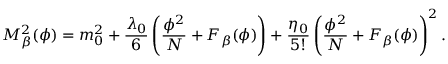<formula> <loc_0><loc_0><loc_500><loc_500>M _ { \beta } ^ { 2 } ( \phi ) = m _ { 0 } ^ { 2 } + \frac { \lambda _ { 0 } } { 6 } \left ( \frac { \phi ^ { 2 } } { N } + F _ { \beta } ( \phi ) \right ) + \frac { \eta _ { 0 } } { 5 ! } \left ( \frac { \phi ^ { 2 } } { N } + F _ { \beta } ( \phi ) \right ) ^ { 2 } .</formula> 